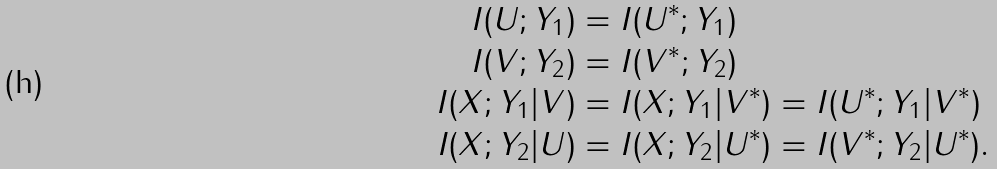Convert formula to latex. <formula><loc_0><loc_0><loc_500><loc_500>I ( U ; Y _ { 1 } ) & = I ( U ^ { * } ; Y _ { 1 } ) \\ I ( V ; Y _ { 2 } ) & = I ( V ^ { * } ; Y _ { 2 } ) \\ I ( X ; Y _ { 1 } | V ) & = I ( X ; Y _ { 1 } | V ^ { * } ) = I ( U ^ { * } ; Y _ { 1 } | V ^ { * } ) \\ I ( X ; Y _ { 2 } | U ) & = I ( X ; Y _ { 2 } | U ^ { * } ) = I ( V ^ { * } ; Y _ { 2 } | U ^ { * } ) .</formula> 